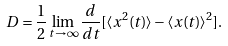<formula> <loc_0><loc_0><loc_500><loc_500>D = \frac { 1 } { 2 } \lim _ { t \rightarrow \infty } \frac { d } { d t } [ \langle x ^ { 2 } ( t ) \rangle - \langle x ( t ) \rangle ^ { 2 } ] .</formula> 